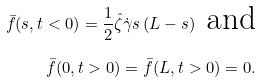<formula> <loc_0><loc_0><loc_500><loc_500>\bar { f } ( s , t < 0 ) = \frac { 1 } { 2 } \hat { \zeta } \dot { \gamma } s \, ( L - s ) \text { and} \\ \bar { f } ( 0 , t > 0 ) = \bar { f } ( L , t > 0 ) = 0 .</formula> 